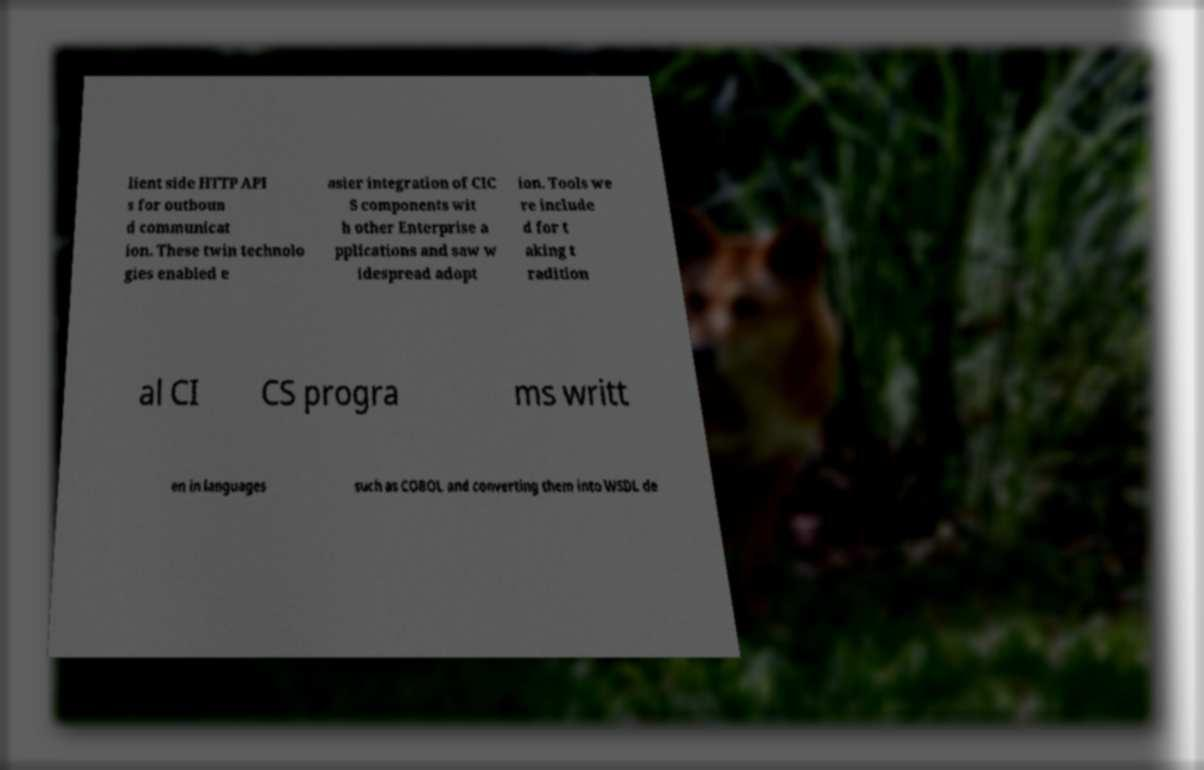I need the written content from this picture converted into text. Can you do that? lient side HTTP API s for outboun d communicat ion. These twin technolo gies enabled e asier integration of CIC S components wit h other Enterprise a pplications and saw w idespread adopt ion. Tools we re include d for t aking t radition al CI CS progra ms writt en in languages such as COBOL and converting them into WSDL de 